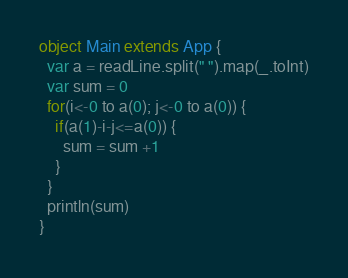<code> <loc_0><loc_0><loc_500><loc_500><_Scala_>object Main extends App {
  var a = readLine.split(" ").map(_.toInt)
  var sum = 0
  for(i<-0 to a(0); j<-0 to a(0)) {
    if(a(1)-i-j<=a(0)) {
      sum = sum +1
    }
  }
  println(sum)
}</code> 